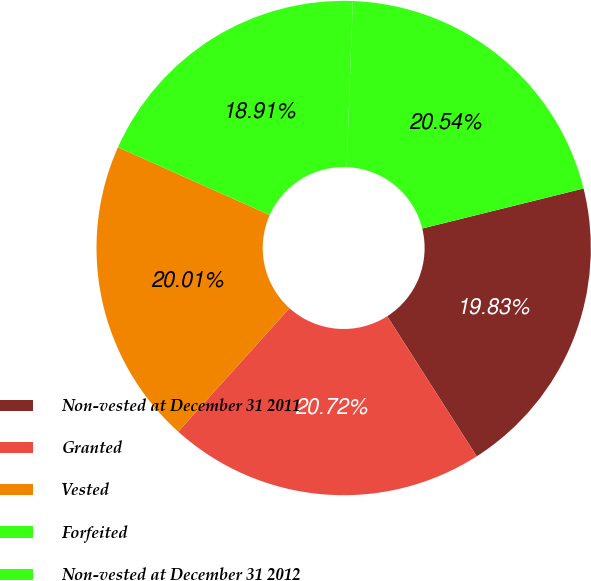<chart> <loc_0><loc_0><loc_500><loc_500><pie_chart><fcel>Non-vested at December 31 2011<fcel>Granted<fcel>Vested<fcel>Forfeited<fcel>Non-vested at December 31 2012<nl><fcel>19.83%<fcel>20.72%<fcel>20.01%<fcel>18.91%<fcel>20.54%<nl></chart> 